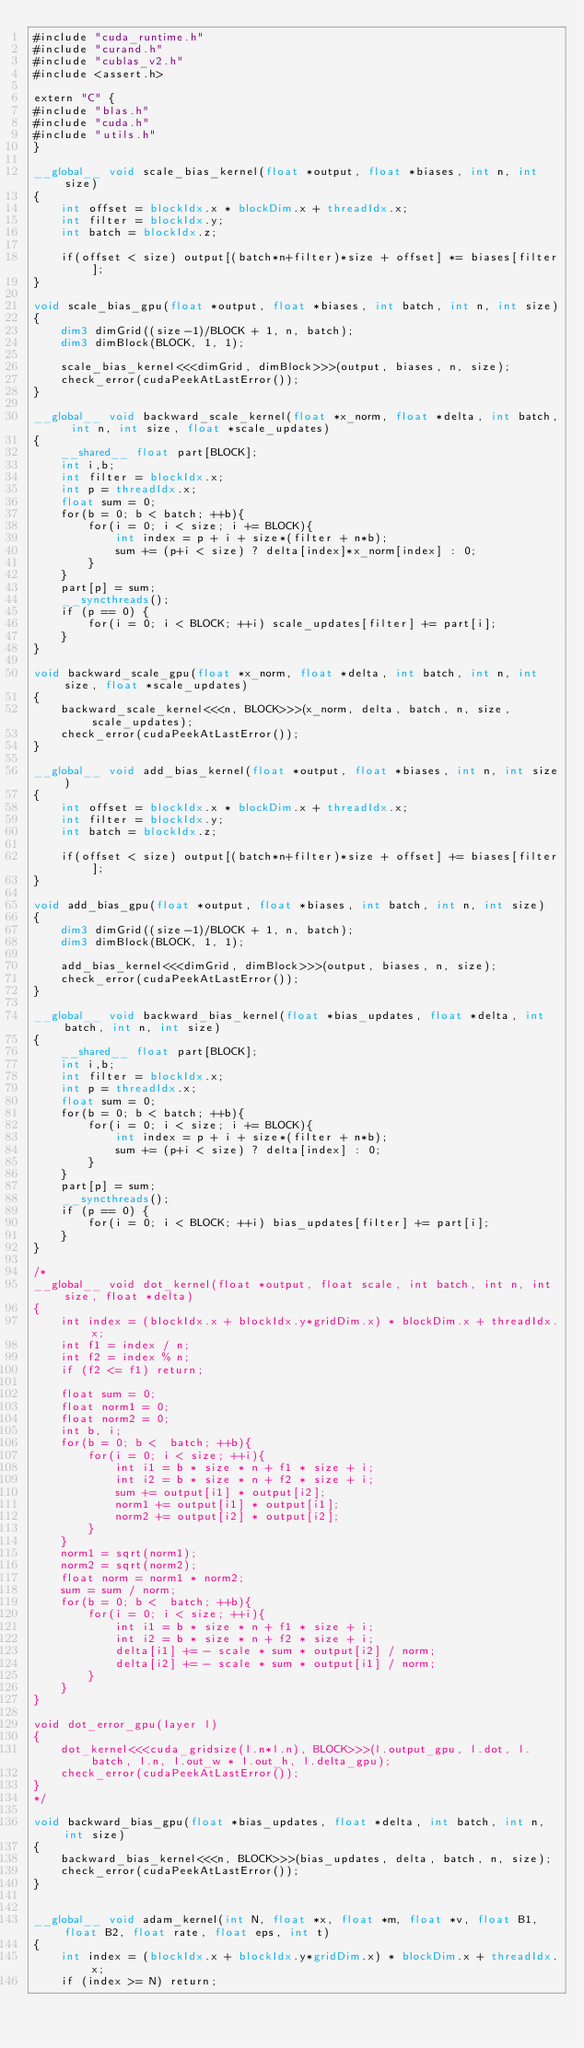<code> <loc_0><loc_0><loc_500><loc_500><_Cuda_>#include "cuda_runtime.h"
#include "curand.h"
#include "cublas_v2.h"
#include <assert.h>

extern "C" {
#include "blas.h"
#include "cuda.h"
#include "utils.h"
}

__global__ void scale_bias_kernel(float *output, float *biases, int n, int size)
{
    int offset = blockIdx.x * blockDim.x + threadIdx.x;
    int filter = blockIdx.y;
    int batch = blockIdx.z;

    if(offset < size) output[(batch*n+filter)*size + offset] *= biases[filter];
}

void scale_bias_gpu(float *output, float *biases, int batch, int n, int size)
{
    dim3 dimGrid((size-1)/BLOCK + 1, n, batch);
    dim3 dimBlock(BLOCK, 1, 1);

    scale_bias_kernel<<<dimGrid, dimBlock>>>(output, biases, n, size);
    check_error(cudaPeekAtLastError());
}

__global__ void backward_scale_kernel(float *x_norm, float *delta, int batch, int n, int size, float *scale_updates)
{
    __shared__ float part[BLOCK];
    int i,b;
    int filter = blockIdx.x;
    int p = threadIdx.x;
    float sum = 0;
    for(b = 0; b < batch; ++b){
        for(i = 0; i < size; i += BLOCK){
            int index = p + i + size*(filter + n*b);
            sum += (p+i < size) ? delta[index]*x_norm[index] : 0;
        }
    }
    part[p] = sum;
    __syncthreads();
    if (p == 0) {
        for(i = 0; i < BLOCK; ++i) scale_updates[filter] += part[i];
    }
}

void backward_scale_gpu(float *x_norm, float *delta, int batch, int n, int size, float *scale_updates)
{
    backward_scale_kernel<<<n, BLOCK>>>(x_norm, delta, batch, n, size, scale_updates);
    check_error(cudaPeekAtLastError());
}

__global__ void add_bias_kernel(float *output, float *biases, int n, int size)
{
    int offset = blockIdx.x * blockDim.x + threadIdx.x;
    int filter = blockIdx.y;
    int batch = blockIdx.z;

    if(offset < size) output[(batch*n+filter)*size + offset] += biases[filter];
}

void add_bias_gpu(float *output, float *biases, int batch, int n, int size)
{
    dim3 dimGrid((size-1)/BLOCK + 1, n, batch);
    dim3 dimBlock(BLOCK, 1, 1);

    add_bias_kernel<<<dimGrid, dimBlock>>>(output, biases, n, size);
    check_error(cudaPeekAtLastError());
}

__global__ void backward_bias_kernel(float *bias_updates, float *delta, int batch, int n, int size)
{
    __shared__ float part[BLOCK];
    int i,b;
    int filter = blockIdx.x;
    int p = threadIdx.x;
    float sum = 0;
    for(b = 0; b < batch; ++b){
        for(i = 0; i < size; i += BLOCK){
            int index = p + i + size*(filter + n*b);
            sum += (p+i < size) ? delta[index] : 0;
        }
    }
    part[p] = sum;
    __syncthreads();
    if (p == 0) {
        for(i = 0; i < BLOCK; ++i) bias_updates[filter] += part[i];
    }
}

/*
__global__ void dot_kernel(float *output, float scale, int batch, int n, int size, float *delta)
{
    int index = (blockIdx.x + blockIdx.y*gridDim.x) * blockDim.x + threadIdx.x;
    int f1 = index / n;
    int f2 = index % n;
    if (f2 <= f1) return;
    
    float sum = 0;
    float norm1 = 0;
    float norm2 = 0;
    int b, i;
    for(b = 0; b <  batch; ++b){
        for(i = 0; i < size; ++i){
            int i1 = b * size * n + f1 * size + i;
            int i2 = b * size * n + f2 * size + i;
            sum += output[i1] * output[i2];
            norm1 += output[i1] * output[i1];
            norm2 += output[i2] * output[i2];
        }
    }
    norm1 = sqrt(norm1);
    norm2 = sqrt(norm2);
    float norm = norm1 * norm2;
    sum = sum / norm;
    for(b = 0; b <  batch; ++b){
        for(i = 0; i < size; ++i){
            int i1 = b * size * n + f1 * size + i;
            int i2 = b * size * n + f2 * size + i;
            delta[i1] += - scale * sum * output[i2] / norm;
            delta[i2] += - scale * sum * output[i1] / norm;
        }
    }
}

void dot_error_gpu(layer l)
{
    dot_kernel<<<cuda_gridsize(l.n*l.n), BLOCK>>>(l.output_gpu, l.dot, l.batch, l.n, l.out_w * l.out_h, l.delta_gpu);
    check_error(cudaPeekAtLastError());
}
*/

void backward_bias_gpu(float *bias_updates, float *delta, int batch, int n, int size)
{
    backward_bias_kernel<<<n, BLOCK>>>(bias_updates, delta, batch, n, size);
    check_error(cudaPeekAtLastError());
}


__global__ void adam_kernel(int N, float *x, float *m, float *v, float B1, float B2, float rate, float eps, int t)
{
    int index = (blockIdx.x + blockIdx.y*gridDim.x) * blockDim.x + threadIdx.x;
    if (index >= N) return;
    </code> 